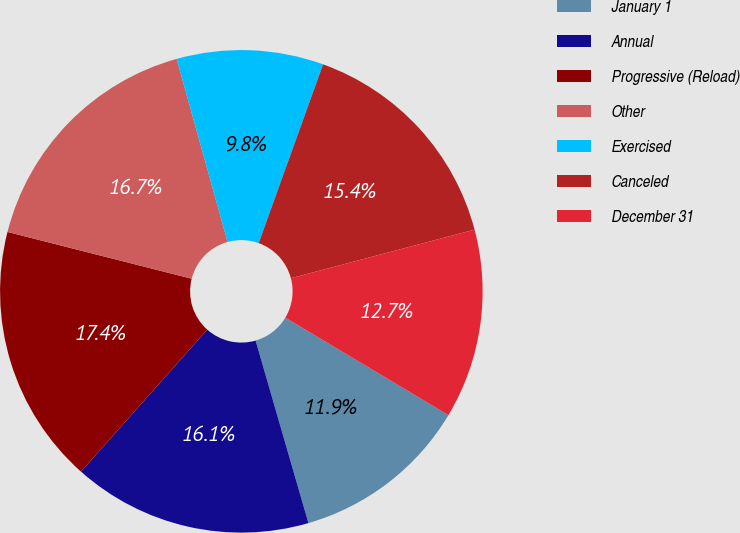Convert chart. <chart><loc_0><loc_0><loc_500><loc_500><pie_chart><fcel>January 1<fcel>Annual<fcel>Progressive (Reload)<fcel>Other<fcel>Exercised<fcel>Canceled<fcel>December 31<nl><fcel>11.94%<fcel>16.05%<fcel>17.39%<fcel>16.72%<fcel>9.82%<fcel>15.38%<fcel>12.69%<nl></chart> 